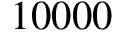<formula> <loc_0><loc_0><loc_500><loc_500>1 0 0 0 0</formula> 